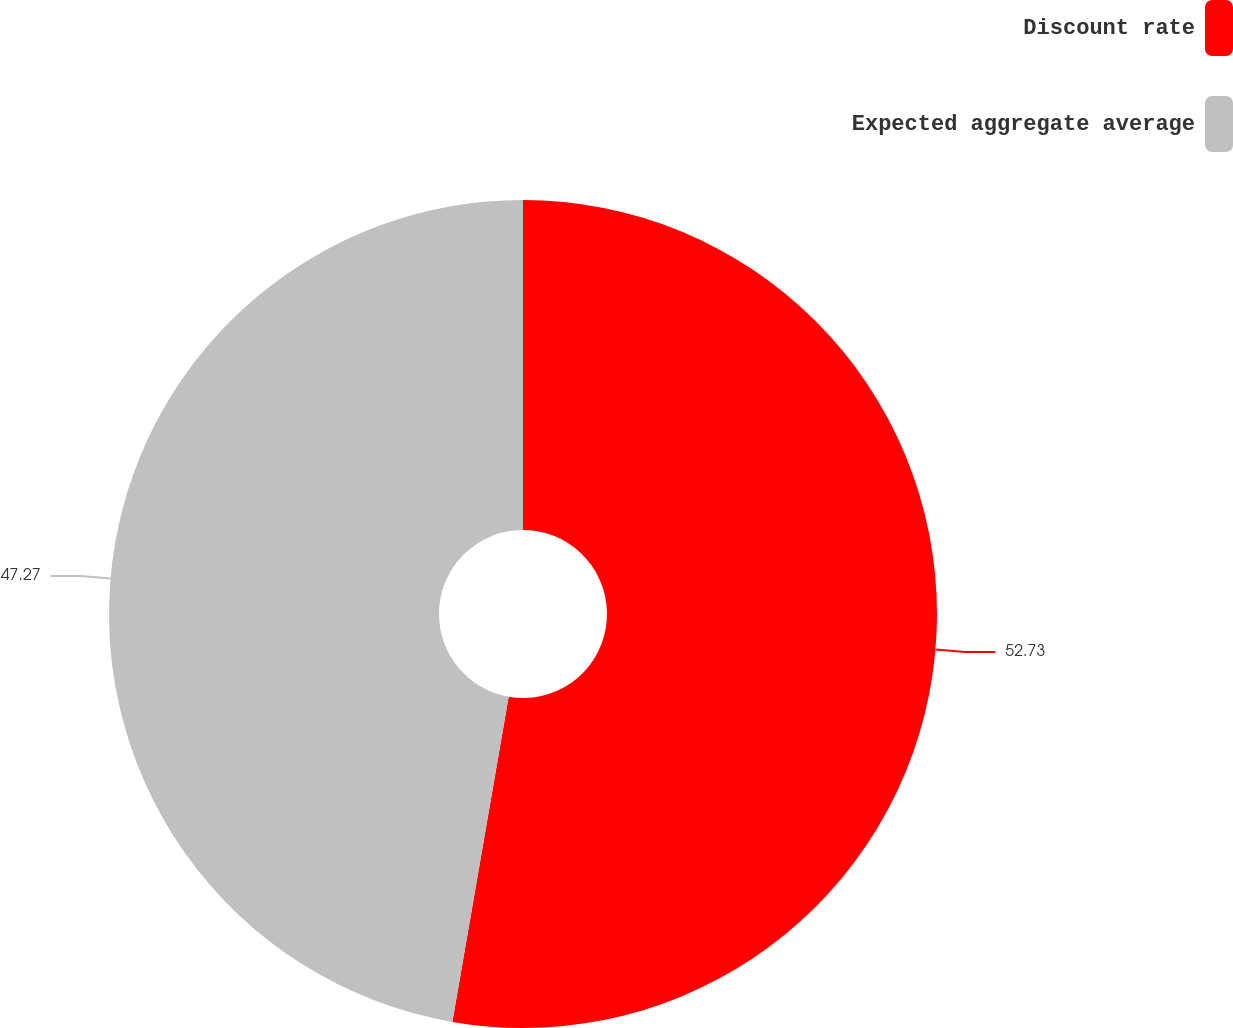Convert chart to OTSL. <chart><loc_0><loc_0><loc_500><loc_500><pie_chart><fcel>Discount rate<fcel>Expected aggregate average<nl><fcel>52.73%<fcel>47.27%<nl></chart> 